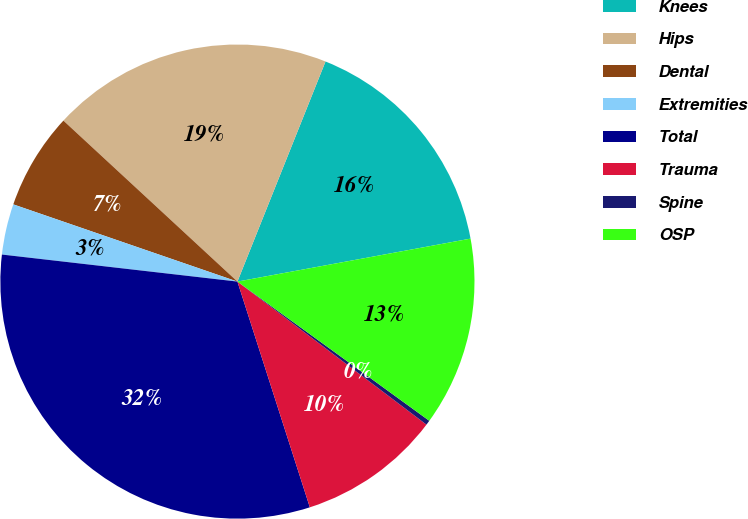Convert chart to OTSL. <chart><loc_0><loc_0><loc_500><loc_500><pie_chart><fcel>Knees<fcel>Hips<fcel>Dental<fcel>Extremities<fcel>Total<fcel>Trauma<fcel>Spine<fcel>OSP<nl><fcel>16.04%<fcel>19.18%<fcel>6.6%<fcel>3.46%<fcel>31.76%<fcel>9.75%<fcel>0.32%<fcel>12.89%<nl></chart> 